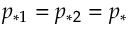<formula> <loc_0><loc_0><loc_500><loc_500>p _ { * 1 } = p _ { * 2 } = p _ { * }</formula> 